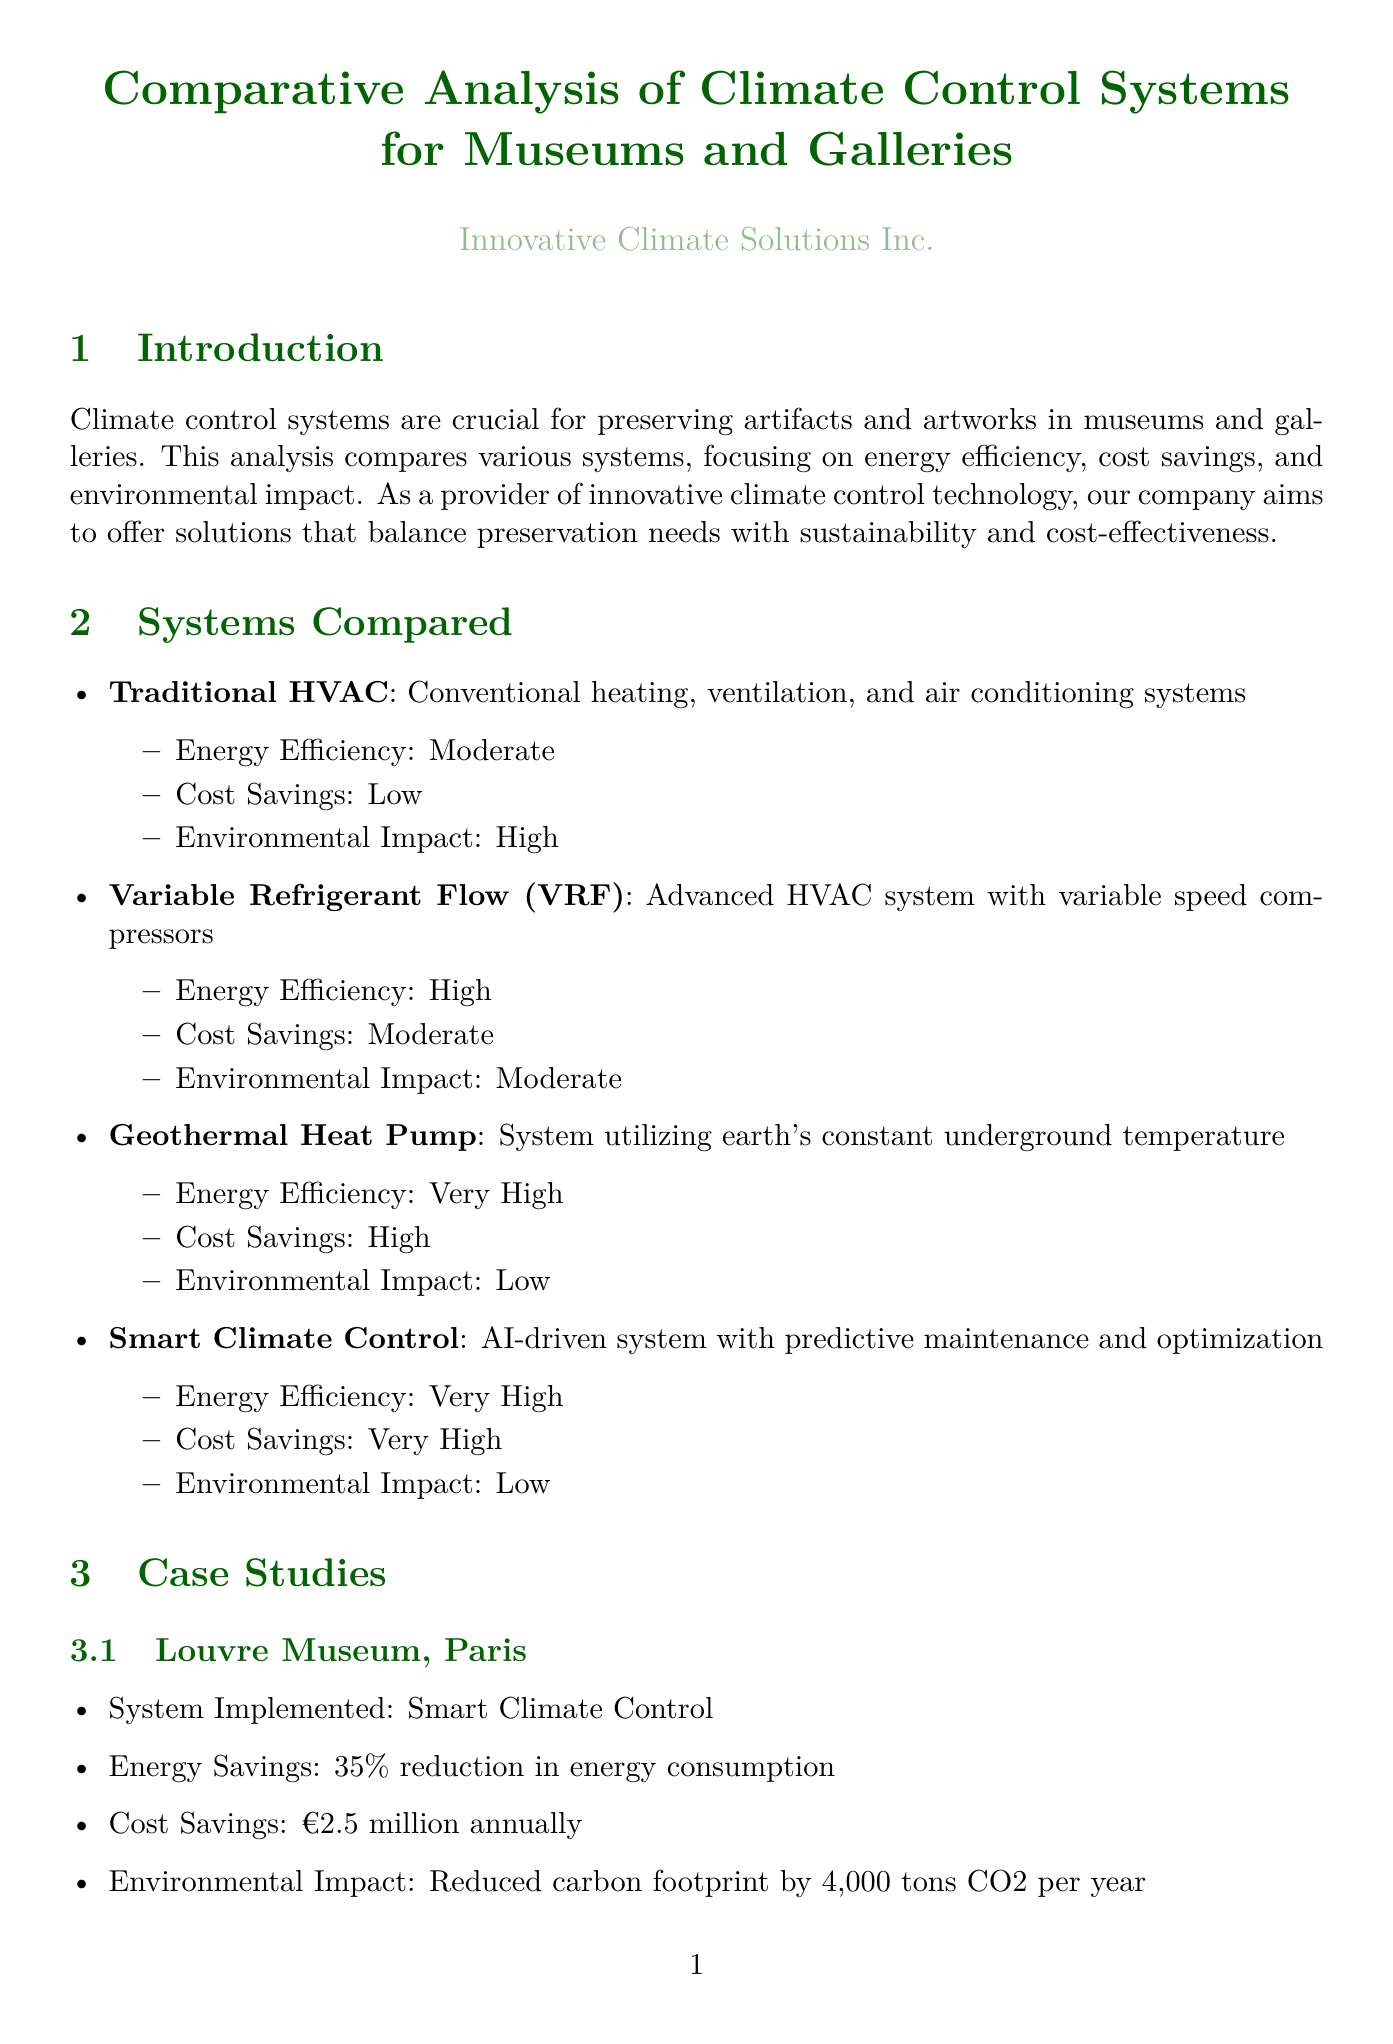What is the primary focus of the analysis? The analysis focuses on comparing various climate control systems, specifically regarding energy efficiency, cost savings, and environmental impact.
Answer: Energy efficiency, cost savings, and environmental impact What are the energy efficiency metrics mentioned? The document lists the energy efficiency metrics that include Annual energy consumption, Energy Use Intensity, ENERGY STAR score, and Coefficient of Performance.
Answer: Annual energy consumption, Energy Use Intensity, ENERGY STAR score, Coefficient of Performance Which system implemented at the Louvre Museum resulted in a €2.5 million annual cost saving? The document states that the Louvre Museum implemented Smart Climate Control, leading to significant cost savings.
Answer: Smart Climate Control What was the environmental impact reduction achieved by the Geothermal Heat Pump at the Smithsonian American Art Museum? The environmental impact was reduced by 50% in carbon emissions as a result of implementing the Geothermal Heat Pump.
Answer: Reduced carbon emissions by 50% What is the return on investment (ROI) formula provided in the cost analysis section? The document provides the formula for calculating ROI as (Net Profit / Cost of Investment) x 100.
Answer: (Net Profit / Cost of Investment) x 100 Which climate control system is described as having a very high energy efficiency and very high cost savings? The document describes both Smart Climate Control and Geothermal Heat Pump as systems that have very high energy efficiency and very high cost savings.
Answer: Smart Climate Control, Geothermal Heat Pump What case study shows a 35% reduction in energy consumption? The analysis highlights the Louvre Museum case study, where the Smart Climate Control system was implemented.
Answer: Louvre Museum, Paris Which certifications are mentioned for environmental impact assessment? The document lists LEED and BREEAM as certifications relevant to environmental impact assessment.
Answer: LEED, BREEAM What future trend involves the use of machine learning algorithms? The document mentions that future trends include the use of machine learning algorithms for predictive maintenance.
Answer: Use of machine learning algorithms for predictive maintenance 